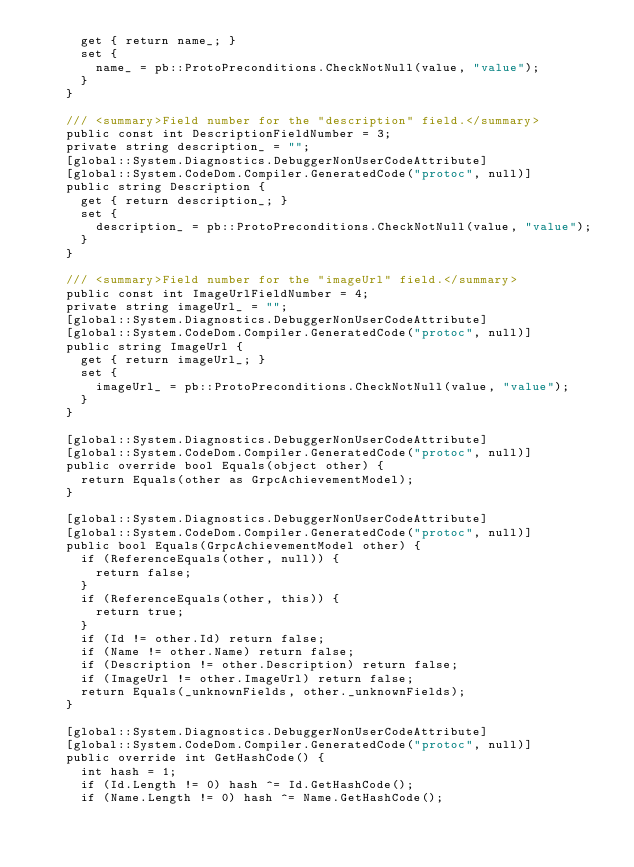Convert code to text. <code><loc_0><loc_0><loc_500><loc_500><_C#_>      get { return name_; }
      set {
        name_ = pb::ProtoPreconditions.CheckNotNull(value, "value");
      }
    }

    /// <summary>Field number for the "description" field.</summary>
    public const int DescriptionFieldNumber = 3;
    private string description_ = "";
    [global::System.Diagnostics.DebuggerNonUserCodeAttribute]
    [global::System.CodeDom.Compiler.GeneratedCode("protoc", null)]
    public string Description {
      get { return description_; }
      set {
        description_ = pb::ProtoPreconditions.CheckNotNull(value, "value");
      }
    }

    /// <summary>Field number for the "imageUrl" field.</summary>
    public const int ImageUrlFieldNumber = 4;
    private string imageUrl_ = "";
    [global::System.Diagnostics.DebuggerNonUserCodeAttribute]
    [global::System.CodeDom.Compiler.GeneratedCode("protoc", null)]
    public string ImageUrl {
      get { return imageUrl_; }
      set {
        imageUrl_ = pb::ProtoPreconditions.CheckNotNull(value, "value");
      }
    }

    [global::System.Diagnostics.DebuggerNonUserCodeAttribute]
    [global::System.CodeDom.Compiler.GeneratedCode("protoc", null)]
    public override bool Equals(object other) {
      return Equals(other as GrpcAchievementModel);
    }

    [global::System.Diagnostics.DebuggerNonUserCodeAttribute]
    [global::System.CodeDom.Compiler.GeneratedCode("protoc", null)]
    public bool Equals(GrpcAchievementModel other) {
      if (ReferenceEquals(other, null)) {
        return false;
      }
      if (ReferenceEquals(other, this)) {
        return true;
      }
      if (Id != other.Id) return false;
      if (Name != other.Name) return false;
      if (Description != other.Description) return false;
      if (ImageUrl != other.ImageUrl) return false;
      return Equals(_unknownFields, other._unknownFields);
    }

    [global::System.Diagnostics.DebuggerNonUserCodeAttribute]
    [global::System.CodeDom.Compiler.GeneratedCode("protoc", null)]
    public override int GetHashCode() {
      int hash = 1;
      if (Id.Length != 0) hash ^= Id.GetHashCode();
      if (Name.Length != 0) hash ^= Name.GetHashCode();</code> 